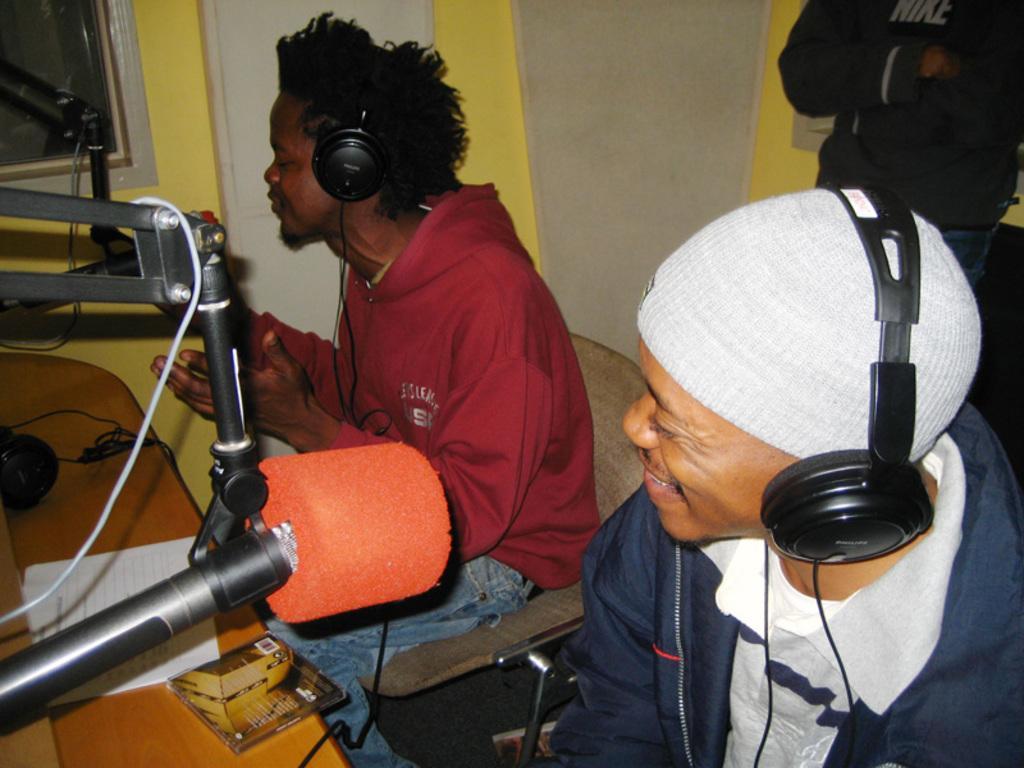How would you summarize this image in a sentence or two? In this image I can see three people with different color dresses. I can see two people sitting in-front of the table and mics. These people are wearing the headsets. On the table I can see the papers, compact disc and wires. In the background I can see the wall. 